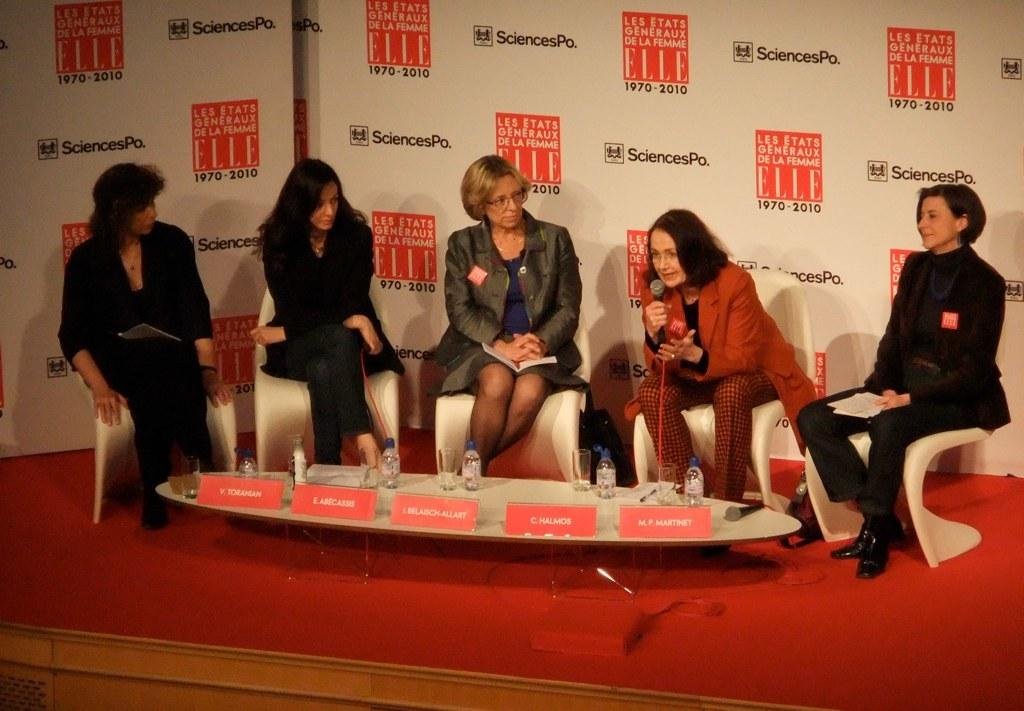What is the main subject of the image? The main subject of the image is the ladies in the center. Can you describe the background of the image? There is a poster in the background of the image. How many sacks are being carried by the fairies in the image? There are no fairies or sacks present in the image. What type of houses can be seen in the background of the image? There are no houses visible in the background of the image; only a poster is present. 